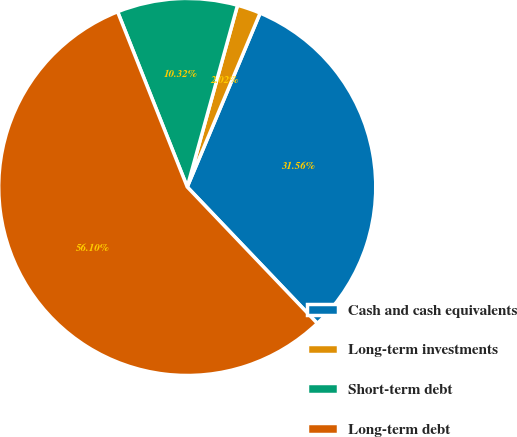Convert chart to OTSL. <chart><loc_0><loc_0><loc_500><loc_500><pie_chart><fcel>Cash and cash equivalents<fcel>Long-term investments<fcel>Short-term debt<fcel>Long-term debt<nl><fcel>31.56%<fcel>2.02%<fcel>10.32%<fcel>56.1%<nl></chart> 